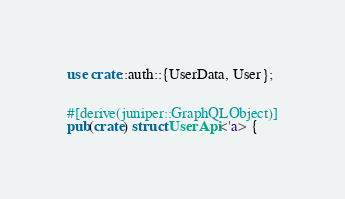<code> <loc_0><loc_0><loc_500><loc_500><_Rust_>use crate::auth::{UserData, User};


#[derive(juniper::GraphQLObject)]
pub(crate) struct UserApi<'a> {</code> 